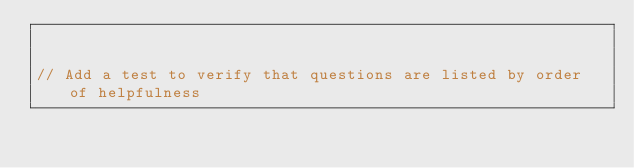Convert code to text. <code><loc_0><loc_0><loc_500><loc_500><_JavaScript_>

// Add a test to verify that questions are listed by order of helpfulness

</code> 